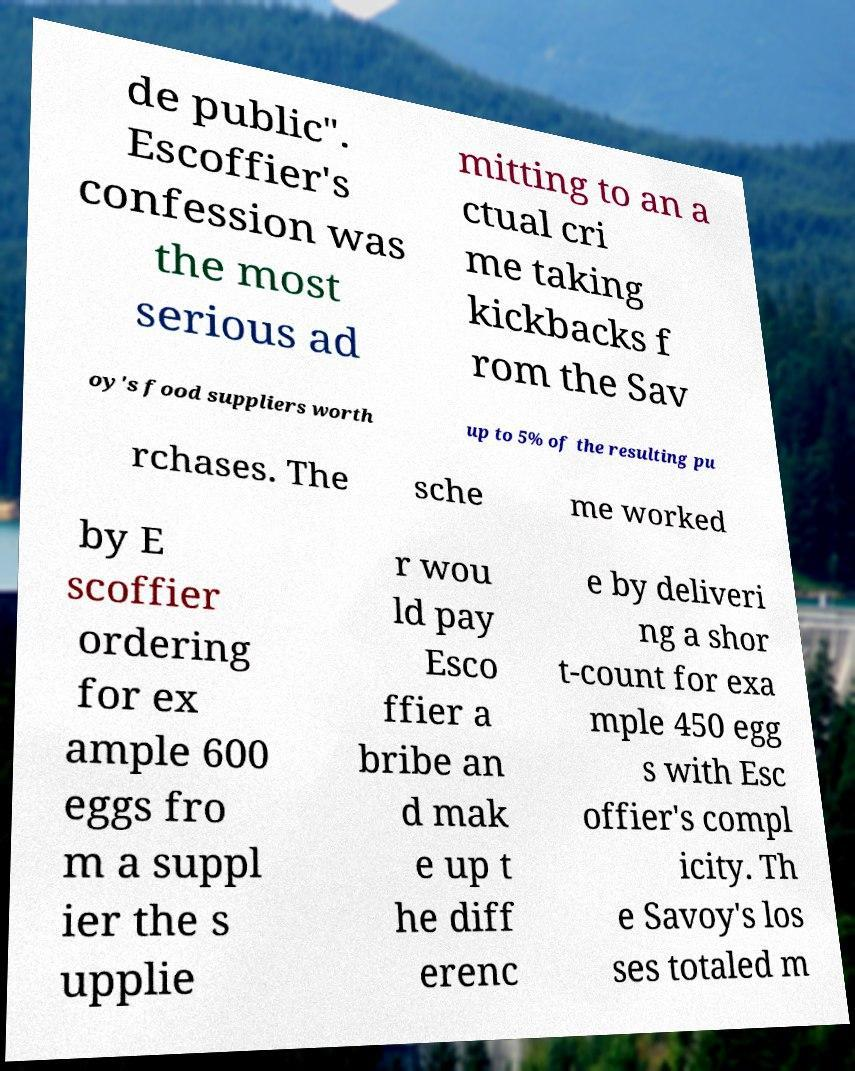Please read and relay the text visible in this image. What does it say? de public". Escoffier's confession was the most serious ad mitting to an a ctual cri me taking kickbacks f rom the Sav oy's food suppliers worth up to 5% of the resulting pu rchases. The sche me worked by E scoffier ordering for ex ample 600 eggs fro m a suppl ier the s upplie r wou ld pay Esco ffier a bribe an d mak e up t he diff erenc e by deliveri ng a shor t-count for exa mple 450 egg s with Esc offier's compl icity. Th e Savoy's los ses totaled m 